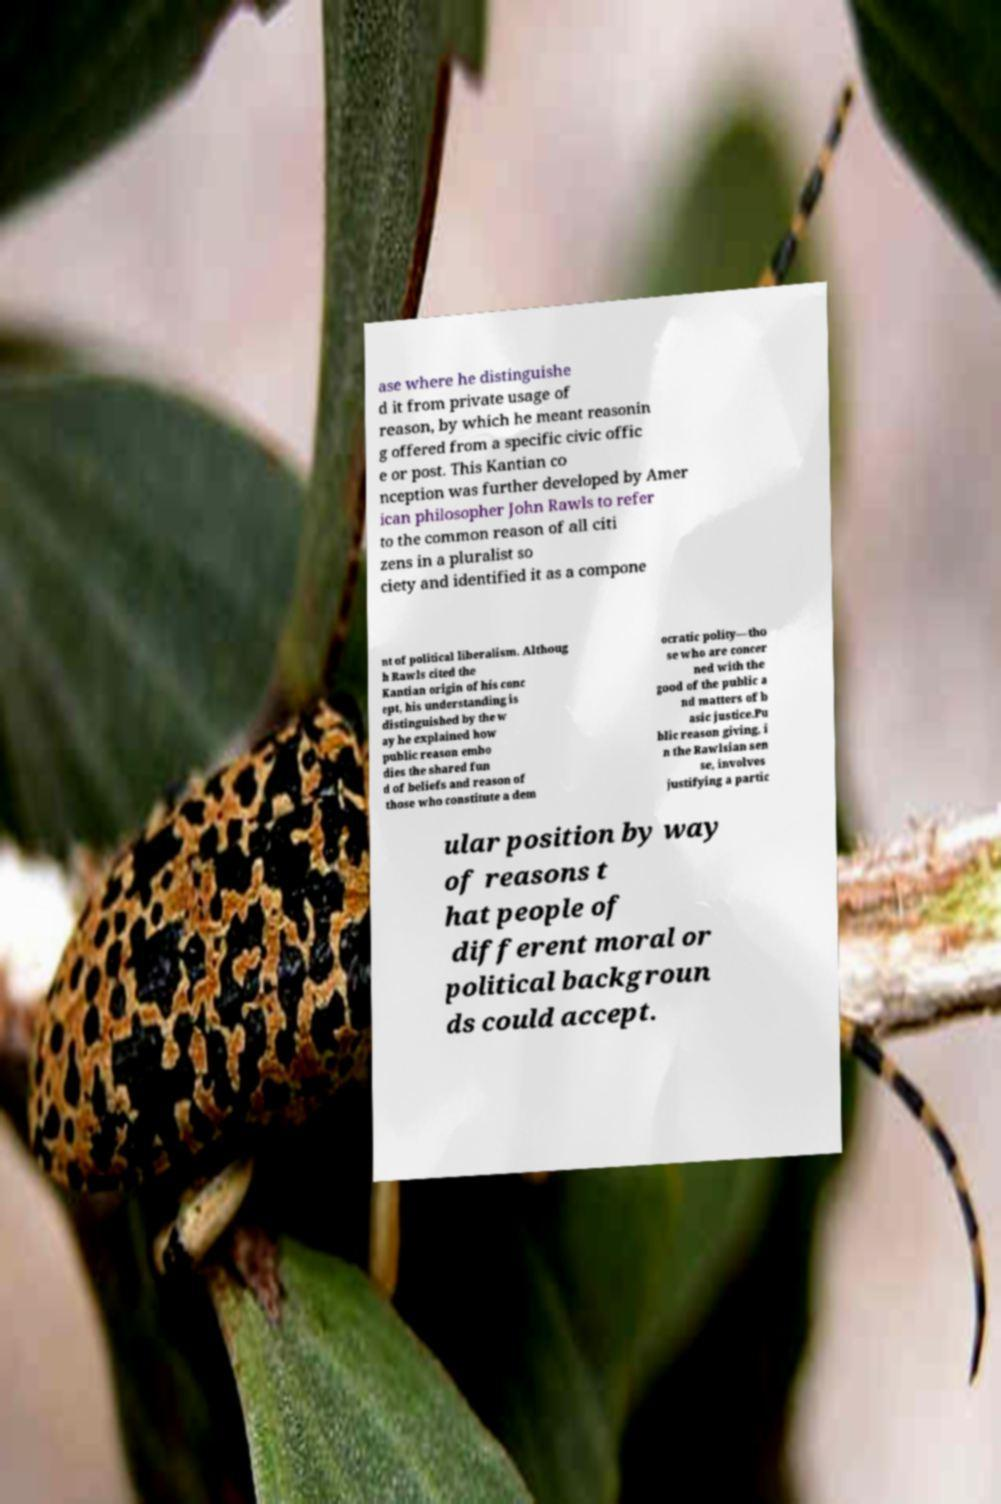Please read and relay the text visible in this image. What does it say? ase where he distinguishe d it from private usage of reason, by which he meant reasonin g offered from a specific civic offic e or post. This Kantian co nception was further developed by Amer ican philosopher John Rawls to refer to the common reason of all citi zens in a pluralist so ciety and identified it as a compone nt of political liberalism. Althoug h Rawls cited the Kantian origin of his conc ept, his understanding is distinguished by the w ay he explained how public reason embo dies the shared fun d of beliefs and reason of those who constitute a dem ocratic polity—tho se who are concer ned with the good of the public a nd matters of b asic justice.Pu blic reason giving, i n the Rawlsian sen se, involves justifying a partic ular position by way of reasons t hat people of different moral or political backgroun ds could accept. 